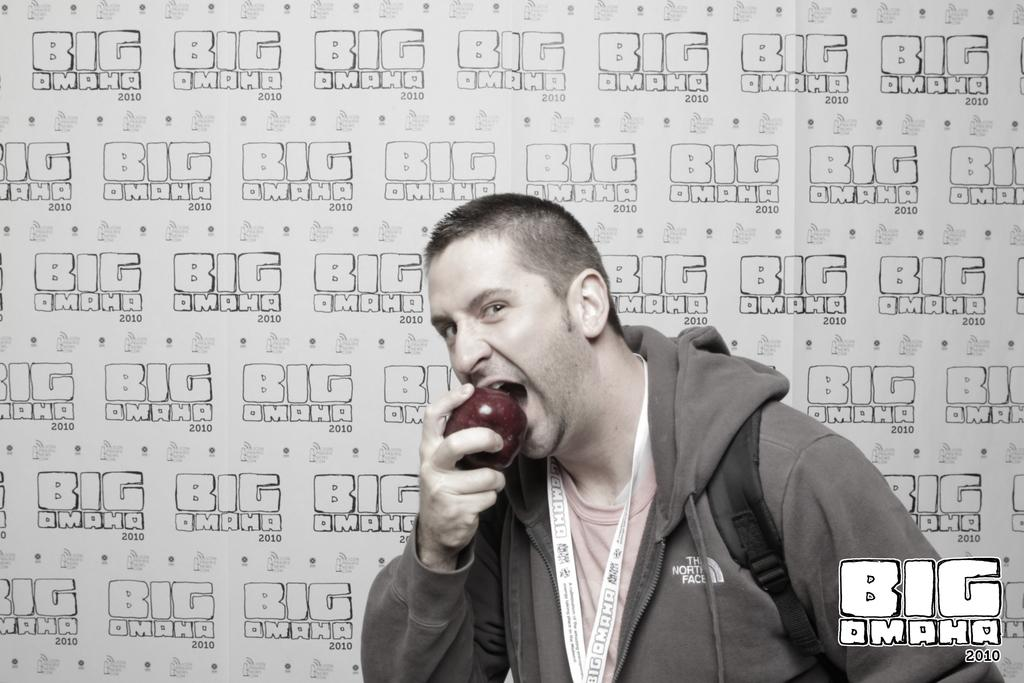Who is present in the image? There is a man in the image. What is the man wearing? The man is wearing a hoodie. What object is the man holding? The man is holding a red apple. Can you describe anything in the background of the image? There is writing visible in the background of the image. Where is the cork located in the image? There is no cork present in the image. Can you see a lake in the background of the image? There is no lake visible in the image. 